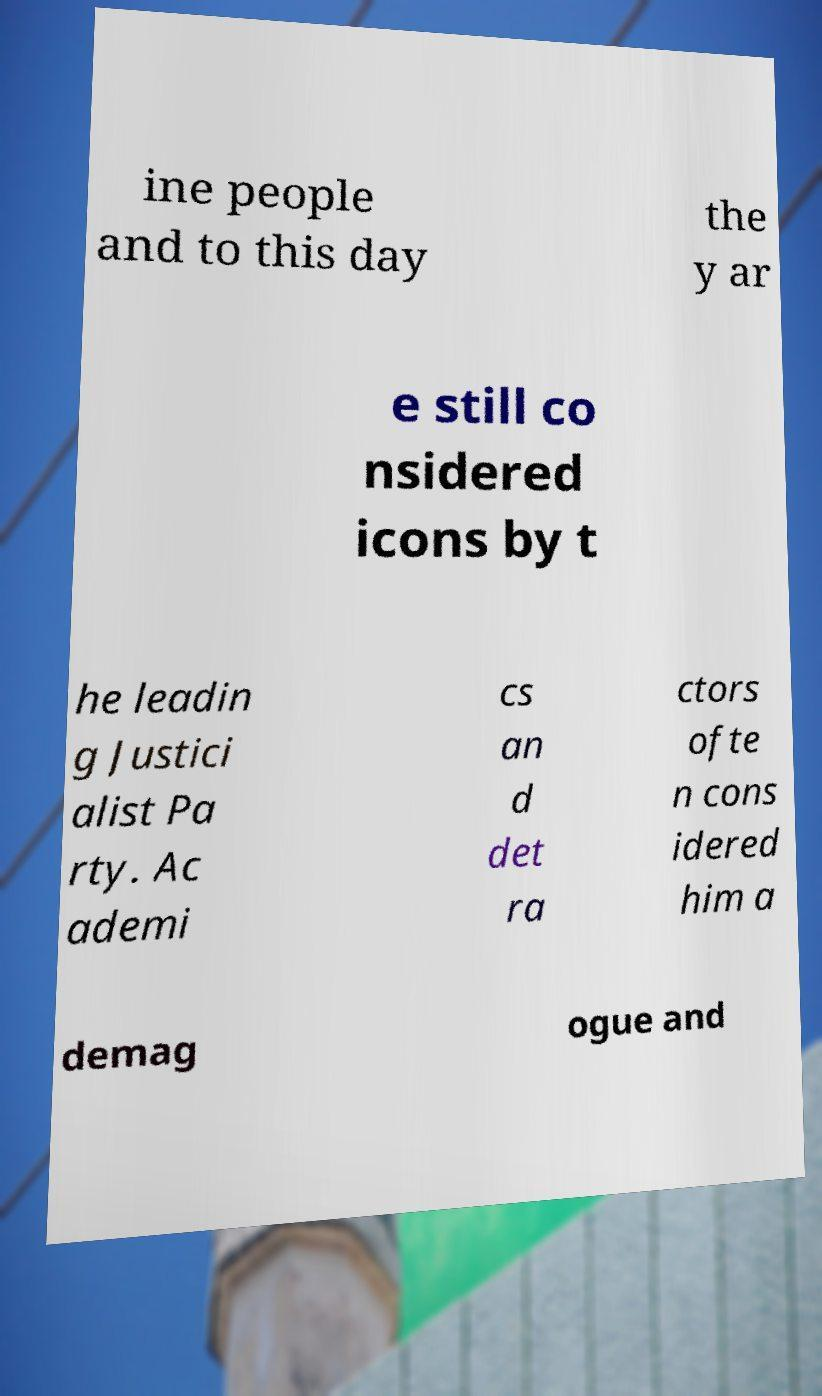Could you extract and type out the text from this image? ine people and to this day the y ar e still co nsidered icons by t he leadin g Justici alist Pa rty. Ac ademi cs an d det ra ctors ofte n cons idered him a demag ogue and 